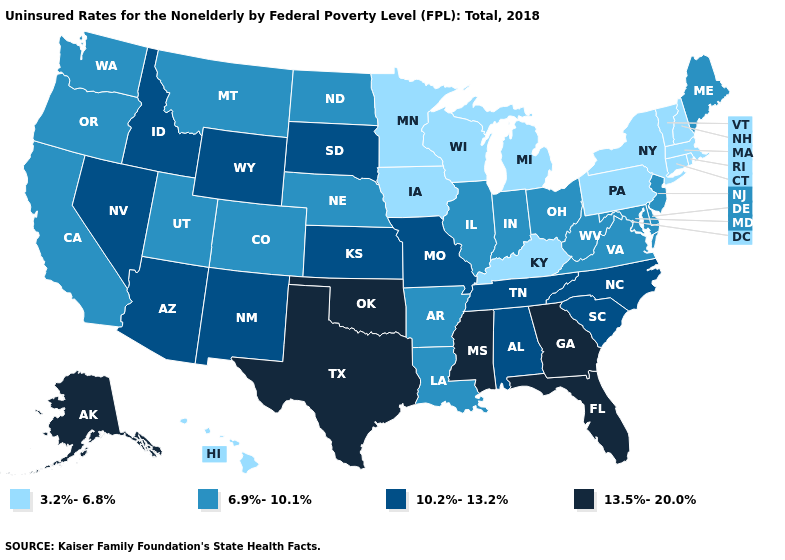Name the states that have a value in the range 10.2%-13.2%?
Concise answer only. Alabama, Arizona, Idaho, Kansas, Missouri, Nevada, New Mexico, North Carolina, South Carolina, South Dakota, Tennessee, Wyoming. Does Kentucky have the lowest value in the South?
Answer briefly. Yes. What is the value of Montana?
Keep it brief. 6.9%-10.1%. Name the states that have a value in the range 6.9%-10.1%?
Concise answer only. Arkansas, California, Colorado, Delaware, Illinois, Indiana, Louisiana, Maine, Maryland, Montana, Nebraska, New Jersey, North Dakota, Ohio, Oregon, Utah, Virginia, Washington, West Virginia. What is the highest value in the MidWest ?
Short answer required. 10.2%-13.2%. Among the states that border California , which have the lowest value?
Quick response, please. Oregon. Is the legend a continuous bar?
Write a very short answer. No. Does Connecticut have a lower value than California?
Keep it brief. Yes. What is the value of Wisconsin?
Quick response, please. 3.2%-6.8%. Name the states that have a value in the range 3.2%-6.8%?
Give a very brief answer. Connecticut, Hawaii, Iowa, Kentucky, Massachusetts, Michigan, Minnesota, New Hampshire, New York, Pennsylvania, Rhode Island, Vermont, Wisconsin. Which states hav the highest value in the West?
Concise answer only. Alaska. What is the value of Maryland?
Keep it brief. 6.9%-10.1%. What is the highest value in the USA?
Give a very brief answer. 13.5%-20.0%. Does Pennsylvania have the lowest value in the Northeast?
Short answer required. Yes. What is the value of Alaska?
Quick response, please. 13.5%-20.0%. 